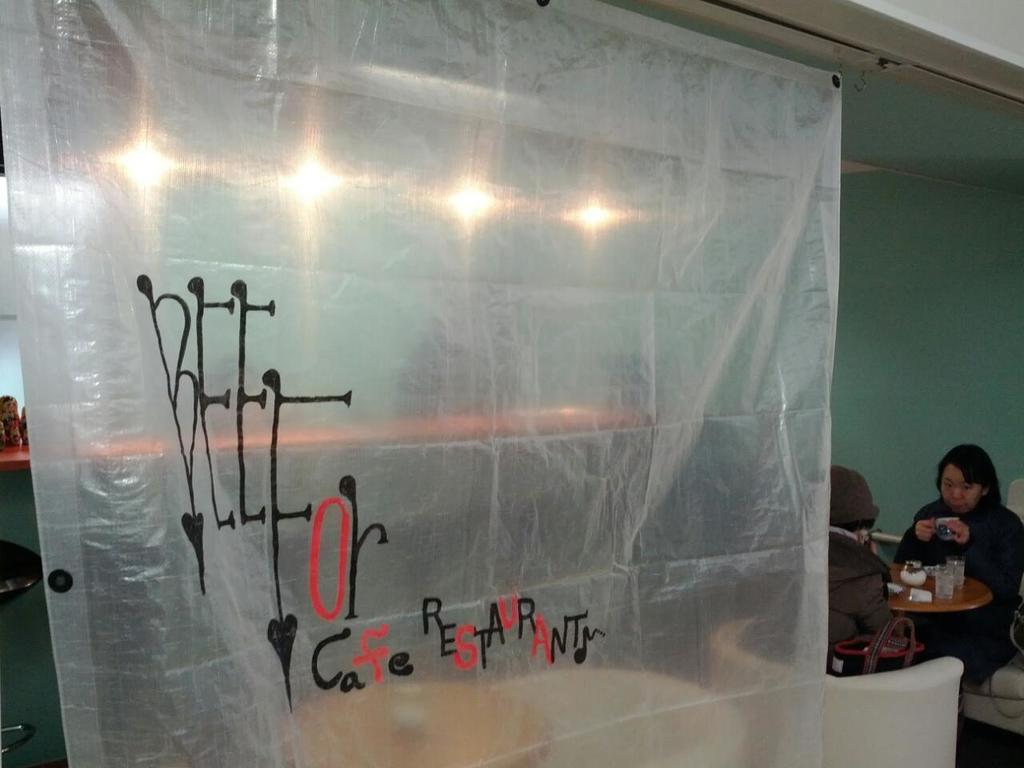Please provide a concise description of this image. In this image I can see a white color fence ,through fence I can see lights and green color wall and I can see two persons in front of the table , on the table I can see glasses visible on the right side. 